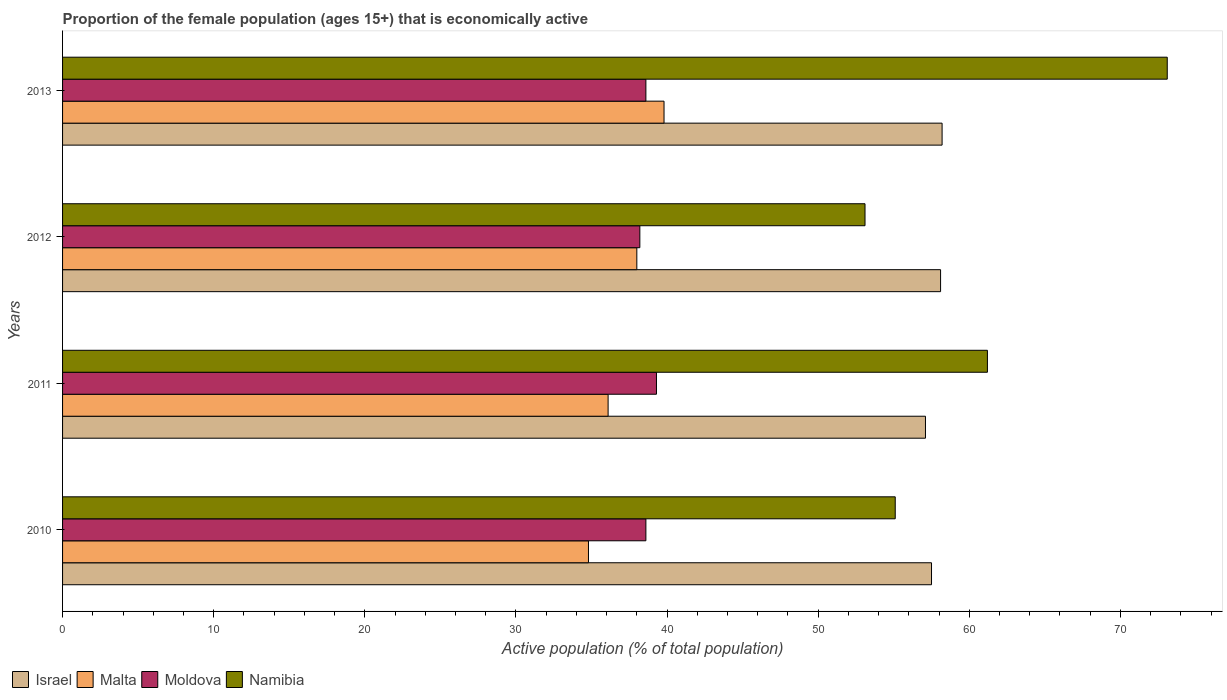How many different coloured bars are there?
Ensure brevity in your answer.  4. How many groups of bars are there?
Give a very brief answer. 4. How many bars are there on the 4th tick from the top?
Your answer should be compact. 4. How many bars are there on the 1st tick from the bottom?
Your answer should be very brief. 4. What is the label of the 2nd group of bars from the top?
Ensure brevity in your answer.  2012. In how many cases, is the number of bars for a given year not equal to the number of legend labels?
Your response must be concise. 0. What is the proportion of the female population that is economically active in Namibia in 2010?
Offer a very short reply. 55.1. Across all years, what is the maximum proportion of the female population that is economically active in Israel?
Your answer should be very brief. 58.2. Across all years, what is the minimum proportion of the female population that is economically active in Malta?
Your answer should be very brief. 34.8. In which year was the proportion of the female population that is economically active in Israel maximum?
Ensure brevity in your answer.  2013. In which year was the proportion of the female population that is economically active in Moldova minimum?
Provide a short and direct response. 2012. What is the total proportion of the female population that is economically active in Malta in the graph?
Give a very brief answer. 148.7. What is the difference between the proportion of the female population that is economically active in Namibia in 2011 and that in 2012?
Offer a very short reply. 8.1. What is the difference between the proportion of the female population that is economically active in Moldova in 2011 and the proportion of the female population that is economically active in Namibia in 2012?
Your response must be concise. -13.8. What is the average proportion of the female population that is economically active in Israel per year?
Ensure brevity in your answer.  57.72. In the year 2010, what is the difference between the proportion of the female population that is economically active in Malta and proportion of the female population that is economically active in Israel?
Your answer should be compact. -22.7. What is the ratio of the proportion of the female population that is economically active in Israel in 2010 to that in 2012?
Provide a short and direct response. 0.99. Is the proportion of the female population that is economically active in Moldova in 2011 less than that in 2013?
Your answer should be very brief. No. Is the difference between the proportion of the female population that is economically active in Malta in 2010 and 2013 greater than the difference between the proportion of the female population that is economically active in Israel in 2010 and 2013?
Your answer should be compact. No. What is the difference between the highest and the second highest proportion of the female population that is economically active in Moldova?
Provide a succinct answer. 0.7. What is the difference between the highest and the lowest proportion of the female population that is economically active in Moldova?
Your answer should be compact. 1.1. Is the sum of the proportion of the female population that is economically active in Namibia in 2011 and 2013 greater than the maximum proportion of the female population that is economically active in Malta across all years?
Offer a terse response. Yes. What does the 2nd bar from the top in 2012 represents?
Your response must be concise. Moldova. What does the 1st bar from the bottom in 2010 represents?
Provide a succinct answer. Israel. How many bars are there?
Keep it short and to the point. 16. How many years are there in the graph?
Provide a succinct answer. 4. What is the difference between two consecutive major ticks on the X-axis?
Your answer should be very brief. 10. Does the graph contain any zero values?
Provide a short and direct response. No. Where does the legend appear in the graph?
Provide a succinct answer. Bottom left. How many legend labels are there?
Ensure brevity in your answer.  4. What is the title of the graph?
Offer a very short reply. Proportion of the female population (ages 15+) that is economically active. What is the label or title of the X-axis?
Give a very brief answer. Active population (% of total population). What is the label or title of the Y-axis?
Your response must be concise. Years. What is the Active population (% of total population) in Israel in 2010?
Your response must be concise. 57.5. What is the Active population (% of total population) of Malta in 2010?
Give a very brief answer. 34.8. What is the Active population (% of total population) in Moldova in 2010?
Ensure brevity in your answer.  38.6. What is the Active population (% of total population) of Namibia in 2010?
Ensure brevity in your answer.  55.1. What is the Active population (% of total population) of Israel in 2011?
Give a very brief answer. 57.1. What is the Active population (% of total population) in Malta in 2011?
Your answer should be compact. 36.1. What is the Active population (% of total population) in Moldova in 2011?
Give a very brief answer. 39.3. What is the Active population (% of total population) of Namibia in 2011?
Ensure brevity in your answer.  61.2. What is the Active population (% of total population) in Israel in 2012?
Your answer should be very brief. 58.1. What is the Active population (% of total population) in Malta in 2012?
Give a very brief answer. 38. What is the Active population (% of total population) in Moldova in 2012?
Offer a terse response. 38.2. What is the Active population (% of total population) in Namibia in 2012?
Your response must be concise. 53.1. What is the Active population (% of total population) in Israel in 2013?
Provide a succinct answer. 58.2. What is the Active population (% of total population) of Malta in 2013?
Offer a very short reply. 39.8. What is the Active population (% of total population) in Moldova in 2013?
Offer a very short reply. 38.6. What is the Active population (% of total population) of Namibia in 2013?
Provide a succinct answer. 73.1. Across all years, what is the maximum Active population (% of total population) in Israel?
Ensure brevity in your answer.  58.2. Across all years, what is the maximum Active population (% of total population) of Malta?
Your answer should be very brief. 39.8. Across all years, what is the maximum Active population (% of total population) in Moldova?
Your answer should be very brief. 39.3. Across all years, what is the maximum Active population (% of total population) in Namibia?
Give a very brief answer. 73.1. Across all years, what is the minimum Active population (% of total population) in Israel?
Your response must be concise. 57.1. Across all years, what is the minimum Active population (% of total population) in Malta?
Provide a succinct answer. 34.8. Across all years, what is the minimum Active population (% of total population) in Moldova?
Give a very brief answer. 38.2. Across all years, what is the minimum Active population (% of total population) of Namibia?
Provide a short and direct response. 53.1. What is the total Active population (% of total population) in Israel in the graph?
Give a very brief answer. 230.9. What is the total Active population (% of total population) of Malta in the graph?
Give a very brief answer. 148.7. What is the total Active population (% of total population) of Moldova in the graph?
Offer a terse response. 154.7. What is the total Active population (% of total population) in Namibia in the graph?
Make the answer very short. 242.5. What is the difference between the Active population (% of total population) of Israel in 2010 and that in 2011?
Your answer should be very brief. 0.4. What is the difference between the Active population (% of total population) of Malta in 2010 and that in 2011?
Offer a terse response. -1.3. What is the difference between the Active population (% of total population) in Israel in 2010 and that in 2012?
Provide a succinct answer. -0.6. What is the difference between the Active population (% of total population) in Malta in 2010 and that in 2012?
Your answer should be very brief. -3.2. What is the difference between the Active population (% of total population) in Moldova in 2010 and that in 2012?
Your response must be concise. 0.4. What is the difference between the Active population (% of total population) in Namibia in 2010 and that in 2012?
Provide a succinct answer. 2. What is the difference between the Active population (% of total population) of Israel in 2010 and that in 2013?
Your answer should be compact. -0.7. What is the difference between the Active population (% of total population) in Malta in 2010 and that in 2013?
Your answer should be compact. -5. What is the difference between the Active population (% of total population) of Moldova in 2010 and that in 2013?
Keep it short and to the point. 0. What is the difference between the Active population (% of total population) in Israel in 2011 and that in 2012?
Your response must be concise. -1. What is the difference between the Active population (% of total population) in Malta in 2011 and that in 2012?
Provide a short and direct response. -1.9. What is the difference between the Active population (% of total population) in Israel in 2011 and that in 2013?
Provide a succinct answer. -1.1. What is the difference between the Active population (% of total population) of Moldova in 2011 and that in 2013?
Your answer should be compact. 0.7. What is the difference between the Active population (% of total population) in Israel in 2012 and that in 2013?
Your response must be concise. -0.1. What is the difference between the Active population (% of total population) of Moldova in 2012 and that in 2013?
Your answer should be compact. -0.4. What is the difference between the Active population (% of total population) of Namibia in 2012 and that in 2013?
Provide a short and direct response. -20. What is the difference between the Active population (% of total population) of Israel in 2010 and the Active population (% of total population) of Malta in 2011?
Ensure brevity in your answer.  21.4. What is the difference between the Active population (% of total population) in Israel in 2010 and the Active population (% of total population) in Moldova in 2011?
Offer a very short reply. 18.2. What is the difference between the Active population (% of total population) of Malta in 2010 and the Active population (% of total population) of Namibia in 2011?
Ensure brevity in your answer.  -26.4. What is the difference between the Active population (% of total population) in Moldova in 2010 and the Active population (% of total population) in Namibia in 2011?
Your answer should be compact. -22.6. What is the difference between the Active population (% of total population) of Israel in 2010 and the Active population (% of total population) of Malta in 2012?
Give a very brief answer. 19.5. What is the difference between the Active population (% of total population) of Israel in 2010 and the Active population (% of total population) of Moldova in 2012?
Your answer should be very brief. 19.3. What is the difference between the Active population (% of total population) in Malta in 2010 and the Active population (% of total population) in Moldova in 2012?
Give a very brief answer. -3.4. What is the difference between the Active population (% of total population) in Malta in 2010 and the Active population (% of total population) in Namibia in 2012?
Make the answer very short. -18.3. What is the difference between the Active population (% of total population) of Moldova in 2010 and the Active population (% of total population) of Namibia in 2012?
Keep it short and to the point. -14.5. What is the difference between the Active population (% of total population) in Israel in 2010 and the Active population (% of total population) in Malta in 2013?
Ensure brevity in your answer.  17.7. What is the difference between the Active population (% of total population) of Israel in 2010 and the Active population (% of total population) of Namibia in 2013?
Your answer should be compact. -15.6. What is the difference between the Active population (% of total population) in Malta in 2010 and the Active population (% of total population) in Namibia in 2013?
Your answer should be compact. -38.3. What is the difference between the Active population (% of total population) in Moldova in 2010 and the Active population (% of total population) in Namibia in 2013?
Provide a short and direct response. -34.5. What is the difference between the Active population (% of total population) in Israel in 2011 and the Active population (% of total population) in Moldova in 2012?
Your answer should be very brief. 18.9. What is the difference between the Active population (% of total population) in Israel in 2011 and the Active population (% of total population) in Namibia in 2012?
Provide a succinct answer. 4. What is the difference between the Active population (% of total population) of Malta in 2011 and the Active population (% of total population) of Namibia in 2012?
Provide a short and direct response. -17. What is the difference between the Active population (% of total population) of Moldova in 2011 and the Active population (% of total population) of Namibia in 2012?
Ensure brevity in your answer.  -13.8. What is the difference between the Active population (% of total population) of Israel in 2011 and the Active population (% of total population) of Malta in 2013?
Ensure brevity in your answer.  17.3. What is the difference between the Active population (% of total population) in Malta in 2011 and the Active population (% of total population) in Moldova in 2013?
Your response must be concise. -2.5. What is the difference between the Active population (% of total population) of Malta in 2011 and the Active population (% of total population) of Namibia in 2013?
Offer a terse response. -37. What is the difference between the Active population (% of total population) of Moldova in 2011 and the Active population (% of total population) of Namibia in 2013?
Your answer should be compact. -33.8. What is the difference between the Active population (% of total population) in Israel in 2012 and the Active population (% of total population) in Malta in 2013?
Your response must be concise. 18.3. What is the difference between the Active population (% of total population) in Israel in 2012 and the Active population (% of total population) in Moldova in 2013?
Provide a succinct answer. 19.5. What is the difference between the Active population (% of total population) in Malta in 2012 and the Active population (% of total population) in Namibia in 2013?
Provide a succinct answer. -35.1. What is the difference between the Active population (% of total population) in Moldova in 2012 and the Active population (% of total population) in Namibia in 2013?
Make the answer very short. -34.9. What is the average Active population (% of total population) of Israel per year?
Give a very brief answer. 57.73. What is the average Active population (% of total population) of Malta per year?
Your answer should be compact. 37.17. What is the average Active population (% of total population) in Moldova per year?
Provide a short and direct response. 38.67. What is the average Active population (% of total population) of Namibia per year?
Your answer should be very brief. 60.62. In the year 2010, what is the difference between the Active population (% of total population) in Israel and Active population (% of total population) in Malta?
Make the answer very short. 22.7. In the year 2010, what is the difference between the Active population (% of total population) of Israel and Active population (% of total population) of Moldova?
Make the answer very short. 18.9. In the year 2010, what is the difference between the Active population (% of total population) in Malta and Active population (% of total population) in Namibia?
Offer a terse response. -20.3. In the year 2010, what is the difference between the Active population (% of total population) in Moldova and Active population (% of total population) in Namibia?
Ensure brevity in your answer.  -16.5. In the year 2011, what is the difference between the Active population (% of total population) in Israel and Active population (% of total population) in Malta?
Ensure brevity in your answer.  21. In the year 2011, what is the difference between the Active population (% of total population) in Israel and Active population (% of total population) in Moldova?
Offer a terse response. 17.8. In the year 2011, what is the difference between the Active population (% of total population) in Malta and Active population (% of total population) in Moldova?
Provide a short and direct response. -3.2. In the year 2011, what is the difference between the Active population (% of total population) of Malta and Active population (% of total population) of Namibia?
Give a very brief answer. -25.1. In the year 2011, what is the difference between the Active population (% of total population) in Moldova and Active population (% of total population) in Namibia?
Provide a succinct answer. -21.9. In the year 2012, what is the difference between the Active population (% of total population) in Israel and Active population (% of total population) in Malta?
Your response must be concise. 20.1. In the year 2012, what is the difference between the Active population (% of total population) in Israel and Active population (% of total population) in Moldova?
Ensure brevity in your answer.  19.9. In the year 2012, what is the difference between the Active population (% of total population) of Israel and Active population (% of total population) of Namibia?
Offer a very short reply. 5. In the year 2012, what is the difference between the Active population (% of total population) of Malta and Active population (% of total population) of Moldova?
Your answer should be very brief. -0.2. In the year 2012, what is the difference between the Active population (% of total population) in Malta and Active population (% of total population) in Namibia?
Your response must be concise. -15.1. In the year 2012, what is the difference between the Active population (% of total population) of Moldova and Active population (% of total population) of Namibia?
Your response must be concise. -14.9. In the year 2013, what is the difference between the Active population (% of total population) in Israel and Active population (% of total population) in Malta?
Your answer should be very brief. 18.4. In the year 2013, what is the difference between the Active population (% of total population) of Israel and Active population (% of total population) of Moldova?
Your answer should be very brief. 19.6. In the year 2013, what is the difference between the Active population (% of total population) in Israel and Active population (% of total population) in Namibia?
Make the answer very short. -14.9. In the year 2013, what is the difference between the Active population (% of total population) in Malta and Active population (% of total population) in Namibia?
Your response must be concise. -33.3. In the year 2013, what is the difference between the Active population (% of total population) of Moldova and Active population (% of total population) of Namibia?
Your answer should be compact. -34.5. What is the ratio of the Active population (% of total population) of Moldova in 2010 to that in 2011?
Offer a terse response. 0.98. What is the ratio of the Active population (% of total population) in Namibia in 2010 to that in 2011?
Your response must be concise. 0.9. What is the ratio of the Active population (% of total population) in Israel in 2010 to that in 2012?
Give a very brief answer. 0.99. What is the ratio of the Active population (% of total population) in Malta in 2010 to that in 2012?
Provide a short and direct response. 0.92. What is the ratio of the Active population (% of total population) of Moldova in 2010 to that in 2012?
Provide a succinct answer. 1.01. What is the ratio of the Active population (% of total population) in Namibia in 2010 to that in 2012?
Offer a very short reply. 1.04. What is the ratio of the Active population (% of total population) in Malta in 2010 to that in 2013?
Offer a terse response. 0.87. What is the ratio of the Active population (% of total population) in Moldova in 2010 to that in 2013?
Your answer should be compact. 1. What is the ratio of the Active population (% of total population) of Namibia in 2010 to that in 2013?
Provide a succinct answer. 0.75. What is the ratio of the Active population (% of total population) of Israel in 2011 to that in 2012?
Provide a succinct answer. 0.98. What is the ratio of the Active population (% of total population) in Moldova in 2011 to that in 2012?
Your answer should be very brief. 1.03. What is the ratio of the Active population (% of total population) in Namibia in 2011 to that in 2012?
Your answer should be compact. 1.15. What is the ratio of the Active population (% of total population) of Israel in 2011 to that in 2013?
Your answer should be compact. 0.98. What is the ratio of the Active population (% of total population) of Malta in 2011 to that in 2013?
Offer a terse response. 0.91. What is the ratio of the Active population (% of total population) of Moldova in 2011 to that in 2013?
Offer a very short reply. 1.02. What is the ratio of the Active population (% of total population) of Namibia in 2011 to that in 2013?
Provide a succinct answer. 0.84. What is the ratio of the Active population (% of total population) of Malta in 2012 to that in 2013?
Your answer should be very brief. 0.95. What is the ratio of the Active population (% of total population) in Moldova in 2012 to that in 2013?
Ensure brevity in your answer.  0.99. What is the ratio of the Active population (% of total population) of Namibia in 2012 to that in 2013?
Offer a very short reply. 0.73. What is the difference between the highest and the second highest Active population (% of total population) in Moldova?
Your response must be concise. 0.7. What is the difference between the highest and the second highest Active population (% of total population) of Namibia?
Ensure brevity in your answer.  11.9. 